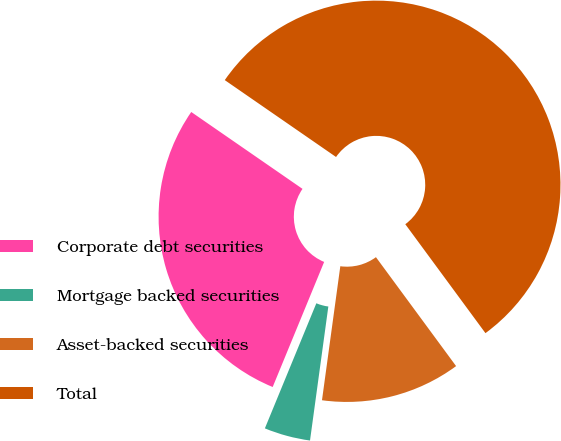Convert chart. <chart><loc_0><loc_0><loc_500><loc_500><pie_chart><fcel>Corporate debt securities<fcel>Mortgage backed securities<fcel>Asset-backed securities<fcel>Total<nl><fcel>28.41%<fcel>4.05%<fcel>12.26%<fcel>55.28%<nl></chart> 